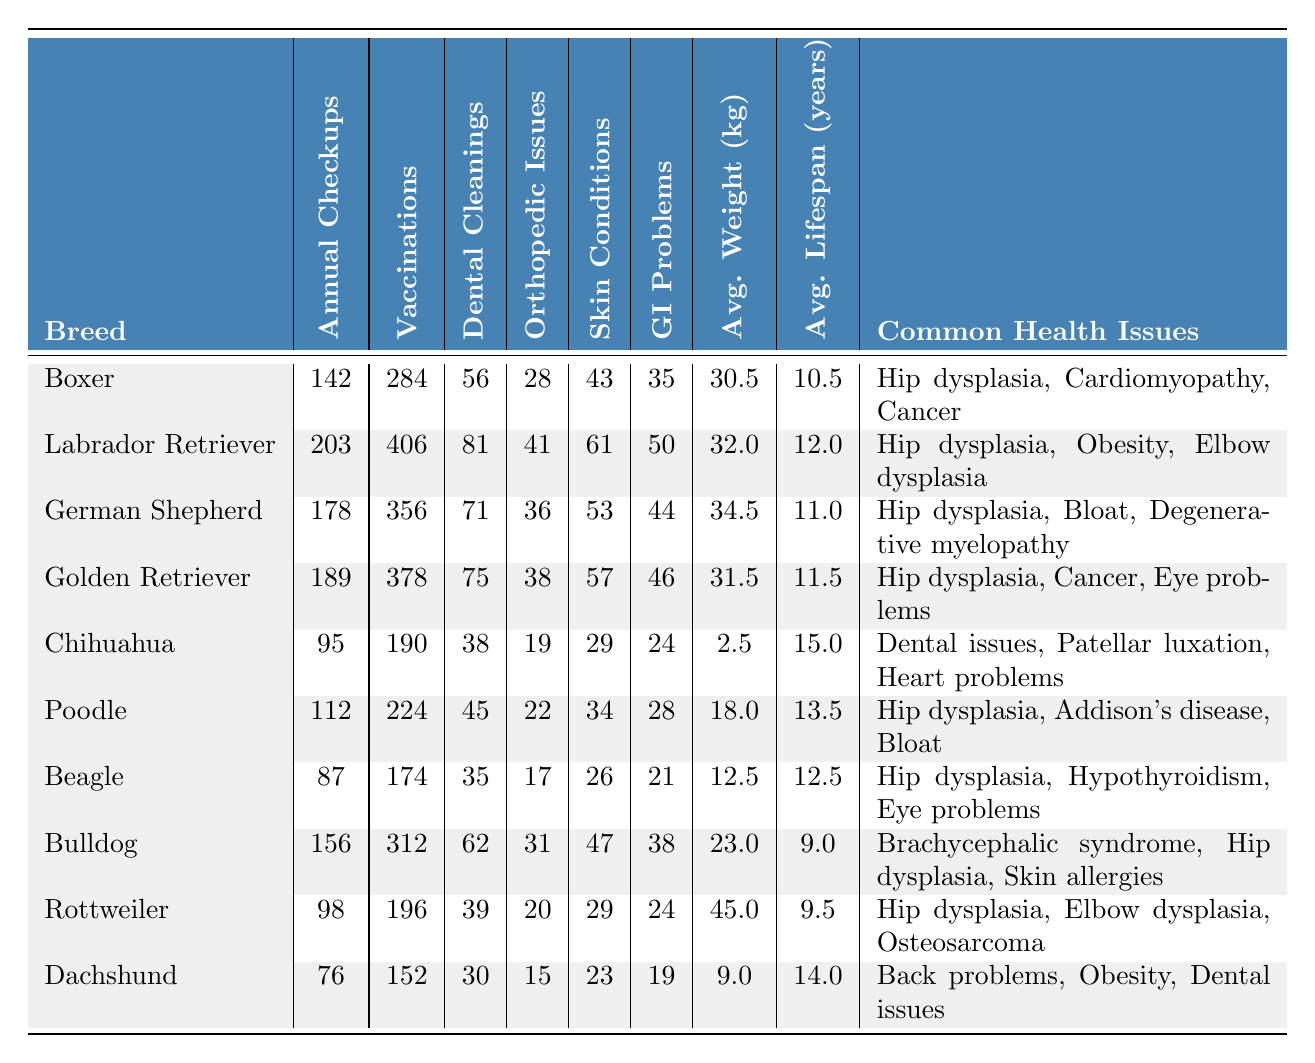What is the breed with the highest number of annual checkups? Looking at the "Annual Checkups" column, the breed with the highest value is the Labrador Retriever, with 203 checkups.
Answer: Labrador Retriever How many dental cleanings were performed on Boxers? According to the "Dental Cleanings" column, Boxers had 56 dental cleanings performed.
Answer: 56 What is the average lifespan for the Chihuahua breed? In the "Average Lifespan (years)" column, the Chihuahua has an average lifespan of 15 years.
Answer: 15 years Which breed has the lowest average weight? The "Average Weight (kg)" column shows that the Chihuahua has the lowest weight at 2.5 kg.
Answer: Chihuahua Is the rate of gastrointestinal problems in Beagles higher than in Bulldogs? Beagles have 21 gastrointestinal problems while Bulldogs have 38. Since 21 is less than 38, the statement is false.
Answer: No How many more vaccinations were administered to Labradors compared to Boxers? The difference in vaccinations is 406 (Labrador) - 284 (Boxer) = 122. So, 122 more vaccinations were given to Labradors.
Answer: 122 What is the total number of orthopedic issues reported for all breeds combined? Summing up the orthopedic issues: 28 + 41 + 36 + 38 + 19 + 22 + 17 + 31 + 20 + 15 = 307. The total number is 307.
Answer: 307 Based on the data, which breed has the highest number of skin conditions? The "Skin Conditions" column shows that the Labrador Retriever has the highest value at 61.
Answer: Labrador Retriever If we consider the average lifespan and the average weight of the breeds, which breed has the lowest weight relative to its lifespan? The Chihuahua has the lowest weight (2.5 kg) and the highest lifespan (15 years). Thus, its weight per lifespan is 2.5/15 = 0.1667 kg/year. Calculating for others, the Beagle follows at 12.5 kg/12.5 years = 1 kg/year, which is much higher. Therefore, the Chihuahua has the lowest weight relative to its average lifespan.
Answer: Chihuahua Are Bulldogs more likely to have dental cleanings compared to Rottweilers? The Bulldogs had 62 dental cleanings while Rottweilers had 39. Since 62 is greater than 39, the answer is yes.
Answer: Yes 